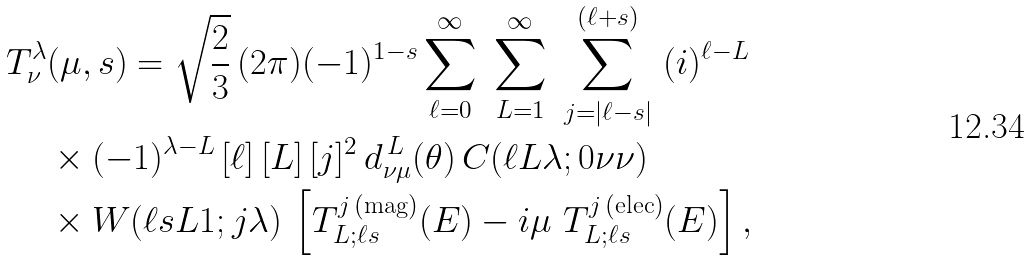Convert formula to latex. <formula><loc_0><loc_0><loc_500><loc_500>T ^ { \lambda } _ { \nu } & ( \mu , s ) = \sqrt { \frac { 2 } { 3 } } \, ( 2 \pi ) ( - 1 ) ^ { 1 - s } \sum _ { \ell = 0 } ^ { \infty } \ \sum _ { L = 1 } ^ { \infty } \ \sum _ { j = | \ell - s | } ^ { ( \ell + s ) } \ ( i ) ^ { \ell - L } \\ & \times ( - 1 ) ^ { \lambda - L } \, [ \ell ] \, [ L ] \, [ j ] ^ { 2 } \, d ^ { \, L } _ { \nu \mu } ( \theta ) \, C ( \ell L \lambda ; 0 \nu \nu ) \\ & \times W ( \ell s L 1 ; j \lambda ) \, \left [ T ^ { j \, ( \text {mag} ) } _ { L ; \ell s } ( E ) - i \mu \ T ^ { j \, ( \text {elec} ) } _ { L ; \ell s } ( E ) \right ] ,</formula> 